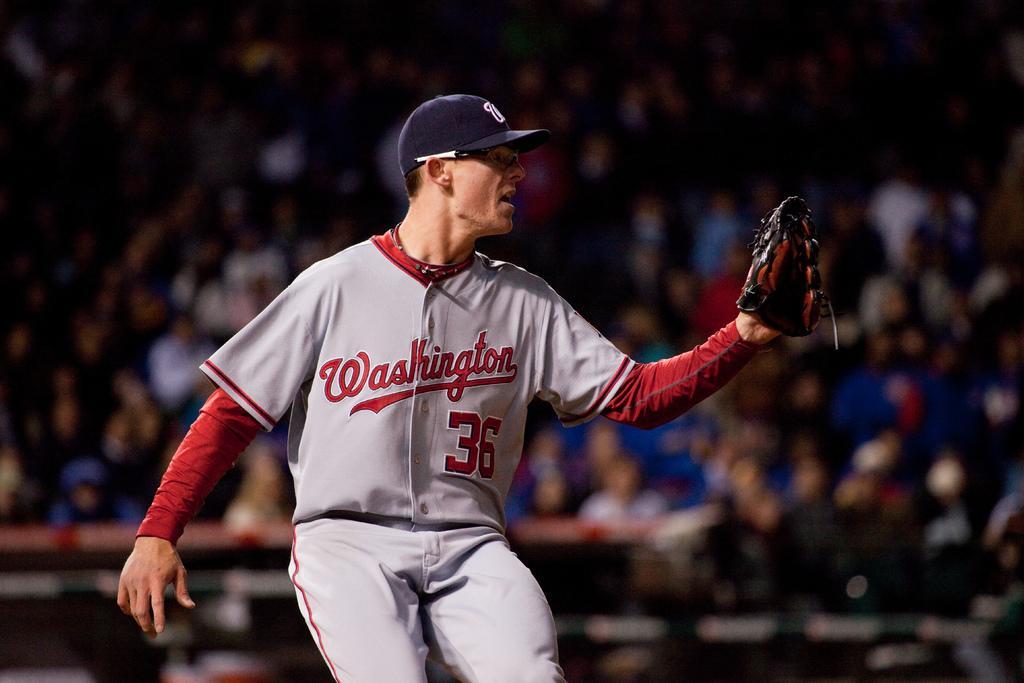How would you summarize this image in a sentence or two? In this picture there is a man in motion and wore glove and cap. In the background of the image it is blurry and we can see people. 